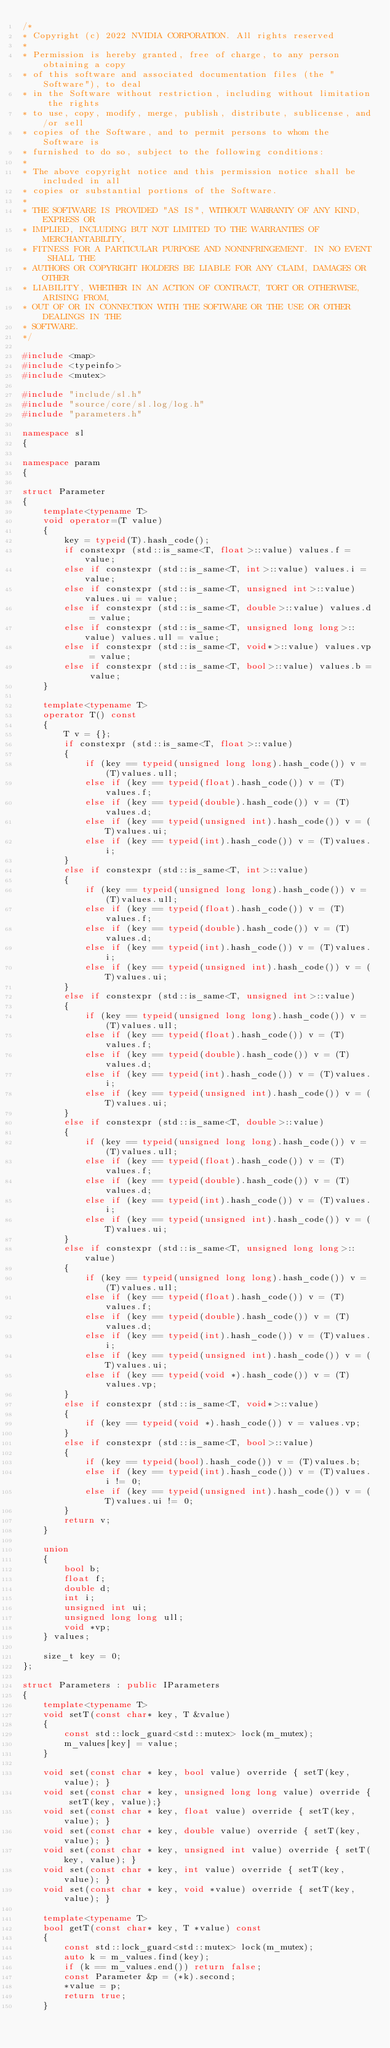Convert code to text. <code><loc_0><loc_0><loc_500><loc_500><_C++_>/*
* Copyright (c) 2022 NVIDIA CORPORATION. All rights reserved
*
* Permission is hereby granted, free of charge, to any person obtaining a copy
* of this software and associated documentation files (the "Software"), to deal
* in the Software without restriction, including without limitation the rights
* to use, copy, modify, merge, publish, distribute, sublicense, and/or sell
* copies of the Software, and to permit persons to whom the Software is
* furnished to do so, subject to the following conditions:
*
* The above copyright notice and this permission notice shall be included in all
* copies or substantial portions of the Software.
*
* THE SOFTWARE IS PROVIDED "AS IS", WITHOUT WARRANTY OF ANY KIND, EXPRESS OR
* IMPLIED, INCLUDING BUT NOT LIMITED TO THE WARRANTIES OF MERCHANTABILITY,
* FITNESS FOR A PARTICULAR PURPOSE AND NONINFRINGEMENT. IN NO EVENT SHALL THE
* AUTHORS OR COPYRIGHT HOLDERS BE LIABLE FOR ANY CLAIM, DAMAGES OR OTHER
* LIABILITY, WHETHER IN AN ACTION OF CONTRACT, TORT OR OTHERWISE, ARISING FROM,
* OUT OF OR IN CONNECTION WITH THE SOFTWARE OR THE USE OR OTHER DEALINGS IN THE
* SOFTWARE.
*/

#include <map>
#include <typeinfo>
#include <mutex>

#include "include/sl.h"
#include "source/core/sl.log/log.h"
#include "parameters.h"

namespace sl
{

namespace param
{
    
struct Parameter
{      
    template<typename T>
    void operator=(T value) 
    { 
        key = typeid(T).hash_code();  
        if constexpr (std::is_same<T, float>::value) values.f = value;        
        else if constexpr (std::is_same<T, int>::value) values.i = value;        
        else if constexpr (std::is_same<T, unsigned int>::value) values.ui = value;        
        else if constexpr (std::is_same<T, double>::value) values.d = value;
        else if constexpr (std::is_same<T, unsigned long long>::value) values.ull = value;
        else if constexpr (std::is_same<T, void*>::value) values.vp = value;        
        else if constexpr (std::is_same<T, bool>::value) values.b = value;
    }
    
    template<typename T>
    operator T() const 
    { 
        T v = {};        
        if constexpr (std::is_same<T, float>::value)
        {
            if (key == typeid(unsigned long long).hash_code()) v = (T)values.ull;
            else if (key == typeid(float).hash_code()) v = (T)values.f;
            else if (key == typeid(double).hash_code()) v = (T)values.d;
            else if (key == typeid(unsigned int).hash_code()) v = (T)values.ui;
            else if (key == typeid(int).hash_code()) v = (T)values.i;
        }
        else if constexpr (std::is_same<T, int>::value)
        {
            if (key == typeid(unsigned long long).hash_code()) v = (T)values.ull;
            else if (key == typeid(float).hash_code()) v = (T)values.f;
            else if (key == typeid(double).hash_code()) v = (T)values.d;
            else if (key == typeid(int).hash_code()) v = (T)values.i;
            else if (key == typeid(unsigned int).hash_code()) v = (T)values.ui;
        }
        else if constexpr (std::is_same<T, unsigned int>::value)
        {
            if (key == typeid(unsigned long long).hash_code()) v = (T)values.ull;
            else if (key == typeid(float).hash_code()) v = (T)values.f;
            else if (key == typeid(double).hash_code()) v = (T)values.d;
            else if (key == typeid(int).hash_code()) v = (T)values.i;
            else if (key == typeid(unsigned int).hash_code()) v = (T)values.ui;
        }
        else if constexpr (std::is_same<T, double>::value)
        {
            if (key == typeid(unsigned long long).hash_code()) v = (T)values.ull;
            else if (key == typeid(float).hash_code()) v = (T)values.f;
            else if (key == typeid(double).hash_code()) v = (T)values.d;
            else if (key == typeid(int).hash_code()) v = (T)values.i;
            else if (key == typeid(unsigned int).hash_code()) v = (T)values.ui;
        }
        else if constexpr (std::is_same<T, unsigned long long>::value)
        {
            if (key == typeid(unsigned long long).hash_code()) v = (T)values.ull;
            else if (key == typeid(float).hash_code()) v = (T)values.f;
            else if (key == typeid(double).hash_code()) v = (T)values.d;
            else if (key == typeid(int).hash_code()) v = (T)values.i;
            else if (key == typeid(unsigned int).hash_code()) v = (T)values.ui;
            else if (key == typeid(void *).hash_code()) v = (T)values.vp;
        }
        else if constexpr (std::is_same<T, void*>::value)
        {
            if (key == typeid(void *).hash_code()) v = values.vp;
        }
        else if constexpr (std::is_same<T, bool>::value)
        {
            if (key == typeid(bool).hash_code()) v = (T)values.b;
            else if (key == typeid(int).hash_code()) v = (T)values.i != 0;
            else if (key == typeid(unsigned int).hash_code()) v = (T)values.ui != 0;
        }
        return v;
    }
    
    union
    {
        bool b;
        float f;
        double d;
        int i;
        unsigned int ui;
        unsigned long long ull;
        void *vp;
    } values;

    size_t key = 0;
};

struct Parameters : public IParameters
{
    template<typename T>
    void setT(const char* key, T &value)
    {
        const std::lock_guard<std::mutex> lock(m_mutex);
        m_values[key] = value;
    }

    void set(const char * key, bool value) override { setT(key, value); }
    void set(const char * key, unsigned long long value) override { setT(key, value);}
    void set(const char * key, float value) override { setT(key, value); }
    void set(const char * key, double value) override { setT(key, value); }
    void set(const char * key, unsigned int value) override { setT(key, value); }
    void set(const char * key, int value) override { setT(key, value); }
    void set(const char * key, void *value) override { setT(key, value); }
    
    template<typename T>
    bool getT(const char* key, T *value) const
    {
        const std::lock_guard<std::mutex> lock(m_mutex);
        auto k = m_values.find(key);
        if (k == m_values.end()) return false;
        const Parameter &p = (*k).second;
        *value = p;
        return true;
    }
</code> 